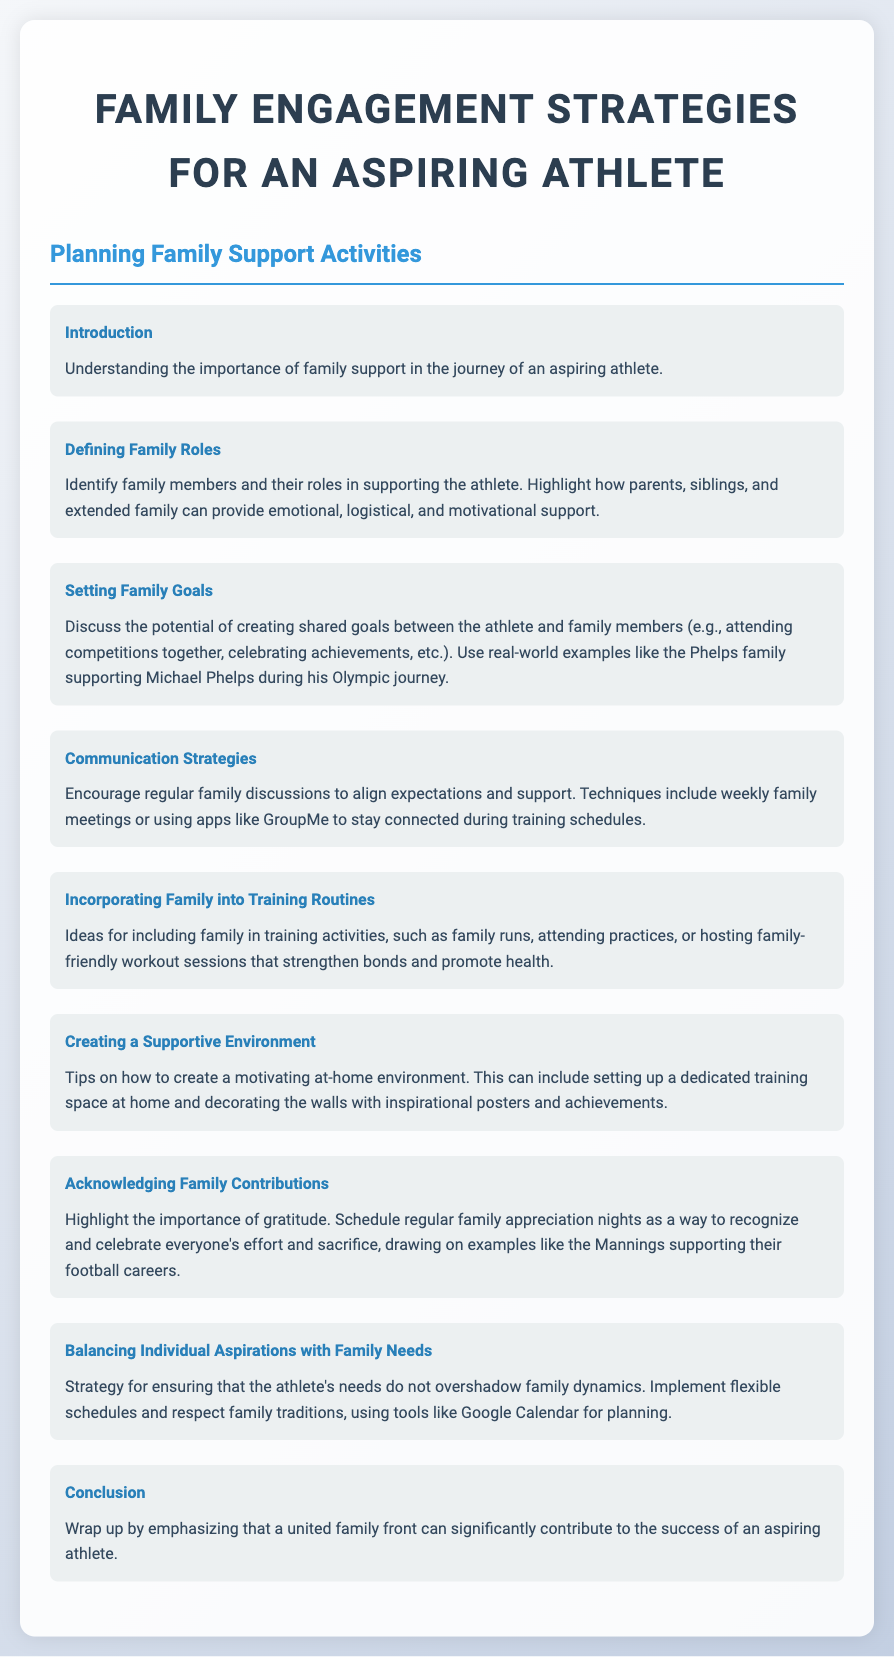What is the title of the document? The title is prominently displayed at the top of the document, which reads "Family Engagement Strategies for an Aspiring Athlete."
Answer: Family Engagement Strategies for an Aspiring Athlete What section discusses family roles? The section titled "Defining Family Roles" addresses the involvement and support of family members in an athlete's journey.
Answer: Defining Family Roles What is one example given for shared family goals? The document mentions creating shared goals like attending competitions together as a way for families to connect with their aspiring athlete.
Answer: Attending competitions together What communication technique is recommended? The document suggests using apps like GroupMe to facilitate staying connected among family members during training schedules.
Answer: GroupMe What is an idea for incorporating family in training? The section "Incorporating Family into Training Routines" mentions hosting family-friendly workout sessions as an inclusive activity.
Answer: Family-friendly workout sessions How can a supportive environment be created? Tips such as setting up a dedicated training space at home are provided to foster a motivating environment for the athlete.
Answer: Dedicated training space What is emphasized in the conclusion? The conclusion highlights the importance of a united family front in contributing to the success of an aspiring athlete.
Answer: United family front What aspect is addressed in "Balancing Individual Aspirations with Family Needs"? The section discusses strategies for ensuring that athletes' needs do not overshadow family dynamics.
Answer: Family dynamics What type of activities can be celebrated during family appreciation nights? The document suggests that family appreciation nights should recognize and celebrate everyone's effort and sacrifice.
Answer: Effort and sacrifice 